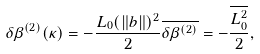<formula> <loc_0><loc_0><loc_500><loc_500>\delta \beta ^ { ( 2 ) } ( \kappa ) = - \frac { L _ { 0 } ( \| b \| ) ^ { 2 } } { 2 } \overline { \delta \beta ^ { ( 2 ) } } = - \frac { \overline { L _ { 0 } ^ { 2 } } } { 2 } ,</formula> 